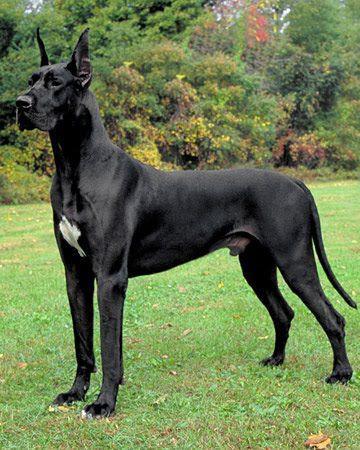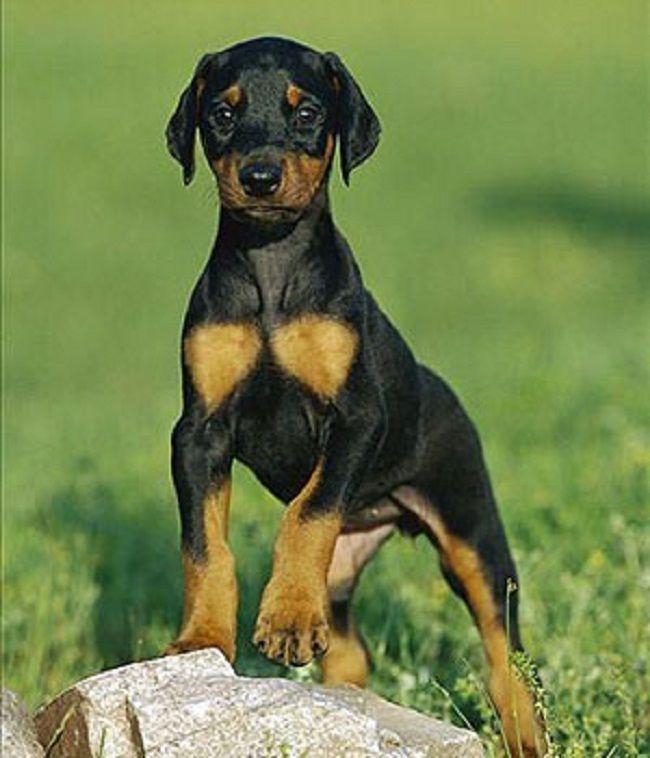The first image is the image on the left, the second image is the image on the right. Examine the images to the left and right. Is the description "One image is a full-grown dog and one is not." accurate? Answer yes or no. Yes. The first image is the image on the left, the second image is the image on the right. For the images displayed, is the sentence "One image shows a single floppy-eared puppy in a standing pose, and the other image shows an adult dog in profile with its body turned leftward." factually correct? Answer yes or no. Yes. 